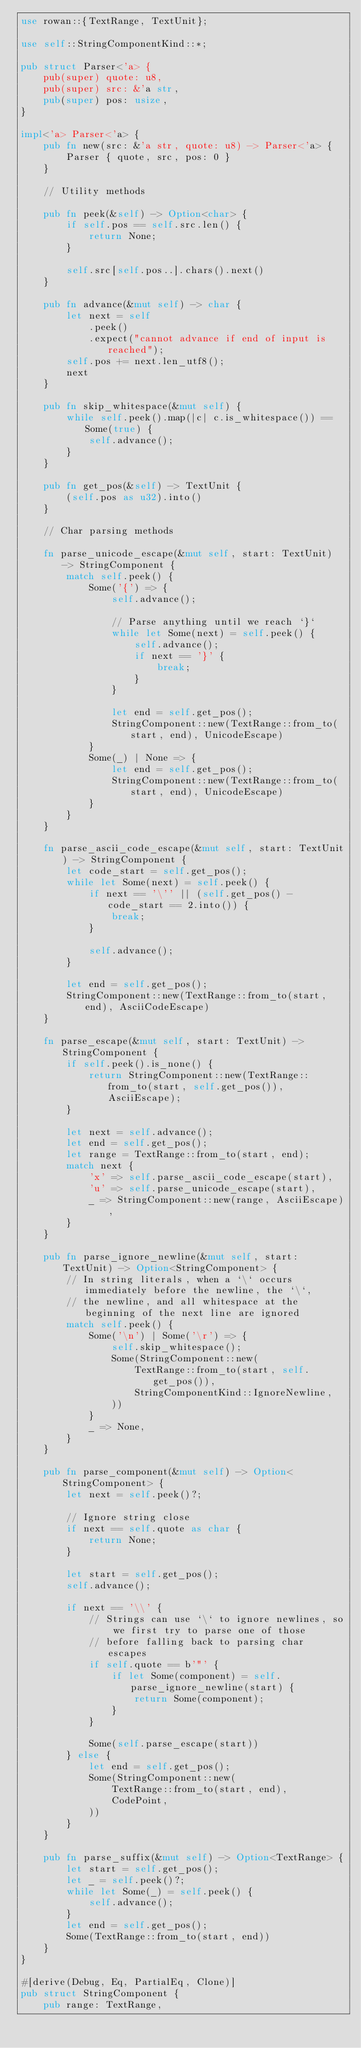Convert code to text. <code><loc_0><loc_0><loc_500><loc_500><_Rust_>use rowan::{TextRange, TextUnit};

use self::StringComponentKind::*;

pub struct Parser<'a> {
    pub(super) quote: u8,
    pub(super) src: &'a str,
    pub(super) pos: usize,
}

impl<'a> Parser<'a> {
    pub fn new(src: &'a str, quote: u8) -> Parser<'a> {
        Parser { quote, src, pos: 0 }
    }

    // Utility methods

    pub fn peek(&self) -> Option<char> {
        if self.pos == self.src.len() {
            return None;
        }

        self.src[self.pos..].chars().next()
    }

    pub fn advance(&mut self) -> char {
        let next = self
            .peek()
            .expect("cannot advance if end of input is reached");
        self.pos += next.len_utf8();
        next
    }

    pub fn skip_whitespace(&mut self) {
        while self.peek().map(|c| c.is_whitespace()) == Some(true) {
            self.advance();
        }
    }

    pub fn get_pos(&self) -> TextUnit {
        (self.pos as u32).into()
    }

    // Char parsing methods

    fn parse_unicode_escape(&mut self, start: TextUnit) -> StringComponent {
        match self.peek() {
            Some('{') => {
                self.advance();

                // Parse anything until we reach `}`
                while let Some(next) = self.peek() {
                    self.advance();
                    if next == '}' {
                        break;
                    }
                }

                let end = self.get_pos();
                StringComponent::new(TextRange::from_to(start, end), UnicodeEscape)
            }
            Some(_) | None => {
                let end = self.get_pos();
                StringComponent::new(TextRange::from_to(start, end), UnicodeEscape)
            }
        }
    }

    fn parse_ascii_code_escape(&mut self, start: TextUnit) -> StringComponent {
        let code_start = self.get_pos();
        while let Some(next) = self.peek() {
            if next == '\'' || (self.get_pos() - code_start == 2.into()) {
                break;
            }

            self.advance();
        }

        let end = self.get_pos();
        StringComponent::new(TextRange::from_to(start, end), AsciiCodeEscape)
    }

    fn parse_escape(&mut self, start: TextUnit) -> StringComponent {
        if self.peek().is_none() {
            return StringComponent::new(TextRange::from_to(start, self.get_pos()), AsciiEscape);
        }

        let next = self.advance();
        let end = self.get_pos();
        let range = TextRange::from_to(start, end);
        match next {
            'x' => self.parse_ascii_code_escape(start),
            'u' => self.parse_unicode_escape(start),
            _ => StringComponent::new(range, AsciiEscape),
        }
    }

    pub fn parse_ignore_newline(&mut self, start: TextUnit) -> Option<StringComponent> {
        // In string literals, when a `\` occurs immediately before the newline, the `\`,
        // the newline, and all whitespace at the beginning of the next line are ignored
        match self.peek() {
            Some('\n') | Some('\r') => {
                self.skip_whitespace();
                Some(StringComponent::new(
                    TextRange::from_to(start, self.get_pos()),
                    StringComponentKind::IgnoreNewline,
                ))
            }
            _ => None,
        }
    }

    pub fn parse_component(&mut self) -> Option<StringComponent> {
        let next = self.peek()?;

        // Ignore string close
        if next == self.quote as char {
            return None;
        }

        let start = self.get_pos();
        self.advance();

        if next == '\\' {
            // Strings can use `\` to ignore newlines, so we first try to parse one of those
            // before falling back to parsing char escapes
            if self.quote == b'"' {
                if let Some(component) = self.parse_ignore_newline(start) {
                    return Some(component);
                }
            }

            Some(self.parse_escape(start))
        } else {
            let end = self.get_pos();
            Some(StringComponent::new(
                TextRange::from_to(start, end),
                CodePoint,
            ))
        }
    }

    pub fn parse_suffix(&mut self) -> Option<TextRange> {
        let start = self.get_pos();
        let _ = self.peek()?;
        while let Some(_) = self.peek() {
            self.advance();
        }
        let end = self.get_pos();
        Some(TextRange::from_to(start, end))
    }
}

#[derive(Debug, Eq, PartialEq, Clone)]
pub struct StringComponent {
    pub range: TextRange,</code> 